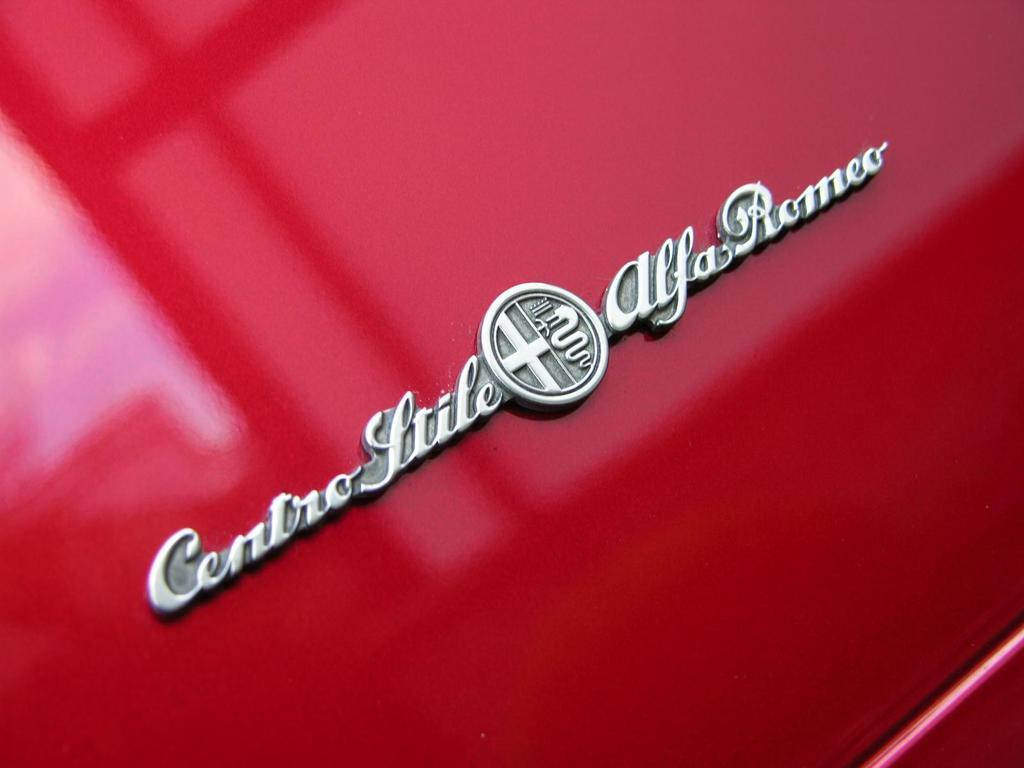What is located in the middle of the picture? There is text and a logo in the middle of the picture. Can you describe the logo? Unfortunately, the description of the logo is not provided in the facts. What color is the background of the image? The background of the image is red. How many balloons are floating in the background of the image? There are no balloons present in the image; the background is red. What type of leather material is used in the text of the image? There is no leather material mentioned or visible in the image. 